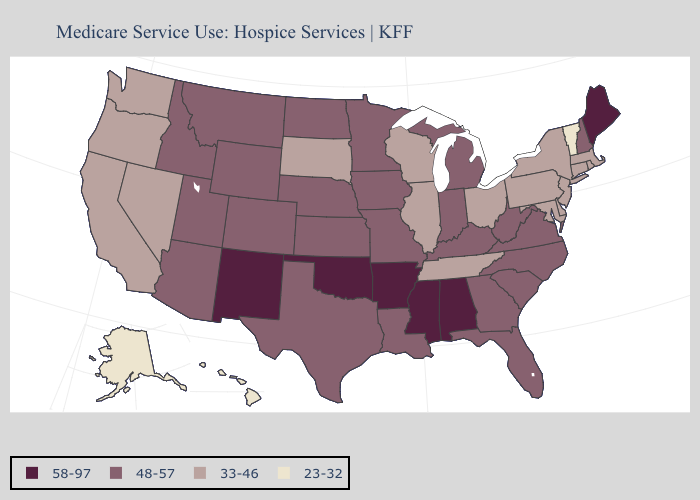What is the value of Virginia?
Answer briefly. 48-57. Among the states that border Washington , which have the highest value?
Quick response, please. Idaho. What is the lowest value in states that border Oklahoma?
Write a very short answer. 48-57. What is the highest value in states that border Virginia?
Be succinct. 48-57. What is the lowest value in the USA?
Short answer required. 23-32. What is the lowest value in the MidWest?
Concise answer only. 33-46. What is the lowest value in the MidWest?
Short answer required. 33-46. What is the value of Maryland?
Short answer required. 33-46. What is the value of Indiana?
Quick response, please. 48-57. Does Maine have the highest value in the USA?
Write a very short answer. Yes. What is the value of Maine?
Answer briefly. 58-97. Name the states that have a value in the range 58-97?
Write a very short answer. Alabama, Arkansas, Maine, Mississippi, New Mexico, Oklahoma. Name the states that have a value in the range 23-32?
Concise answer only. Alaska, Hawaii, Vermont. What is the value of Utah?
Give a very brief answer. 48-57. What is the highest value in the South ?
Keep it brief. 58-97. 